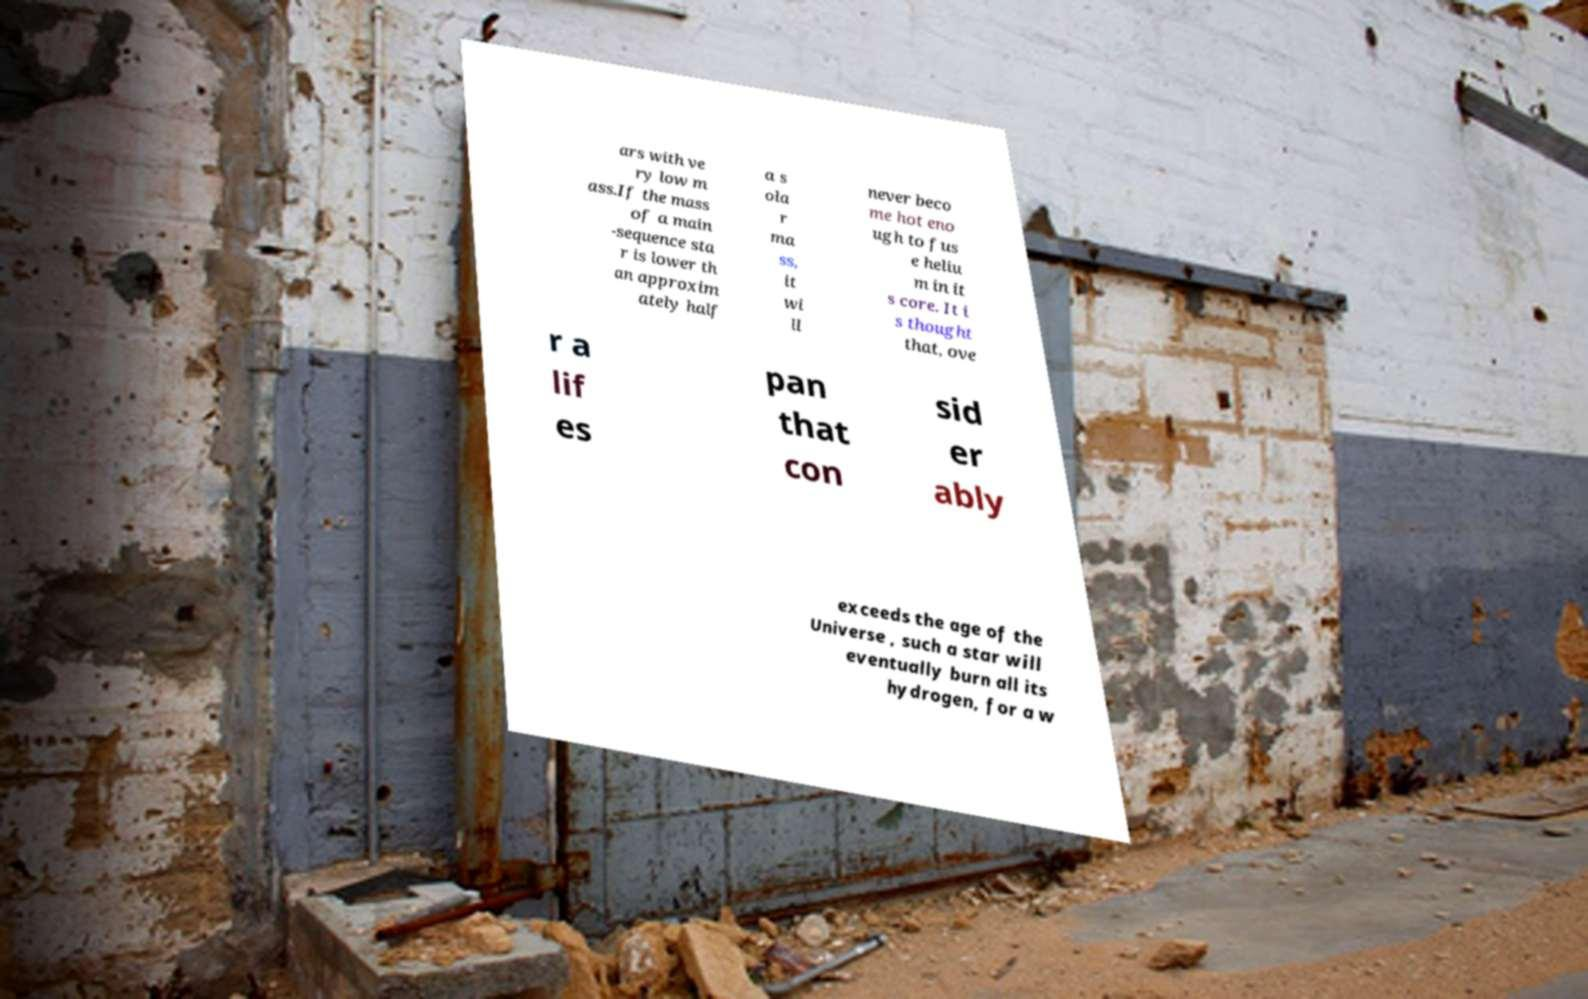For documentation purposes, I need the text within this image transcribed. Could you provide that? ars with ve ry low m ass.If the mass of a main -sequence sta r is lower th an approxim ately half a s ola r ma ss, it wi ll never beco me hot eno ugh to fus e heliu m in it s core. It i s thought that, ove r a lif es pan that con sid er ably exceeds the age of the Universe , such a star will eventually burn all its hydrogen, for a w 